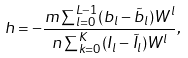<formula> <loc_0><loc_0><loc_500><loc_500>h = - \frac { m \sum _ { l = 0 } ^ { L - 1 } ( b _ { l } - \tilde { b } _ { l } ) W ^ { l } } { n \sum _ { k = 0 } ^ { K } ( I _ { l } - \tilde { I } _ { l } ) W ^ { l } } ,</formula> 